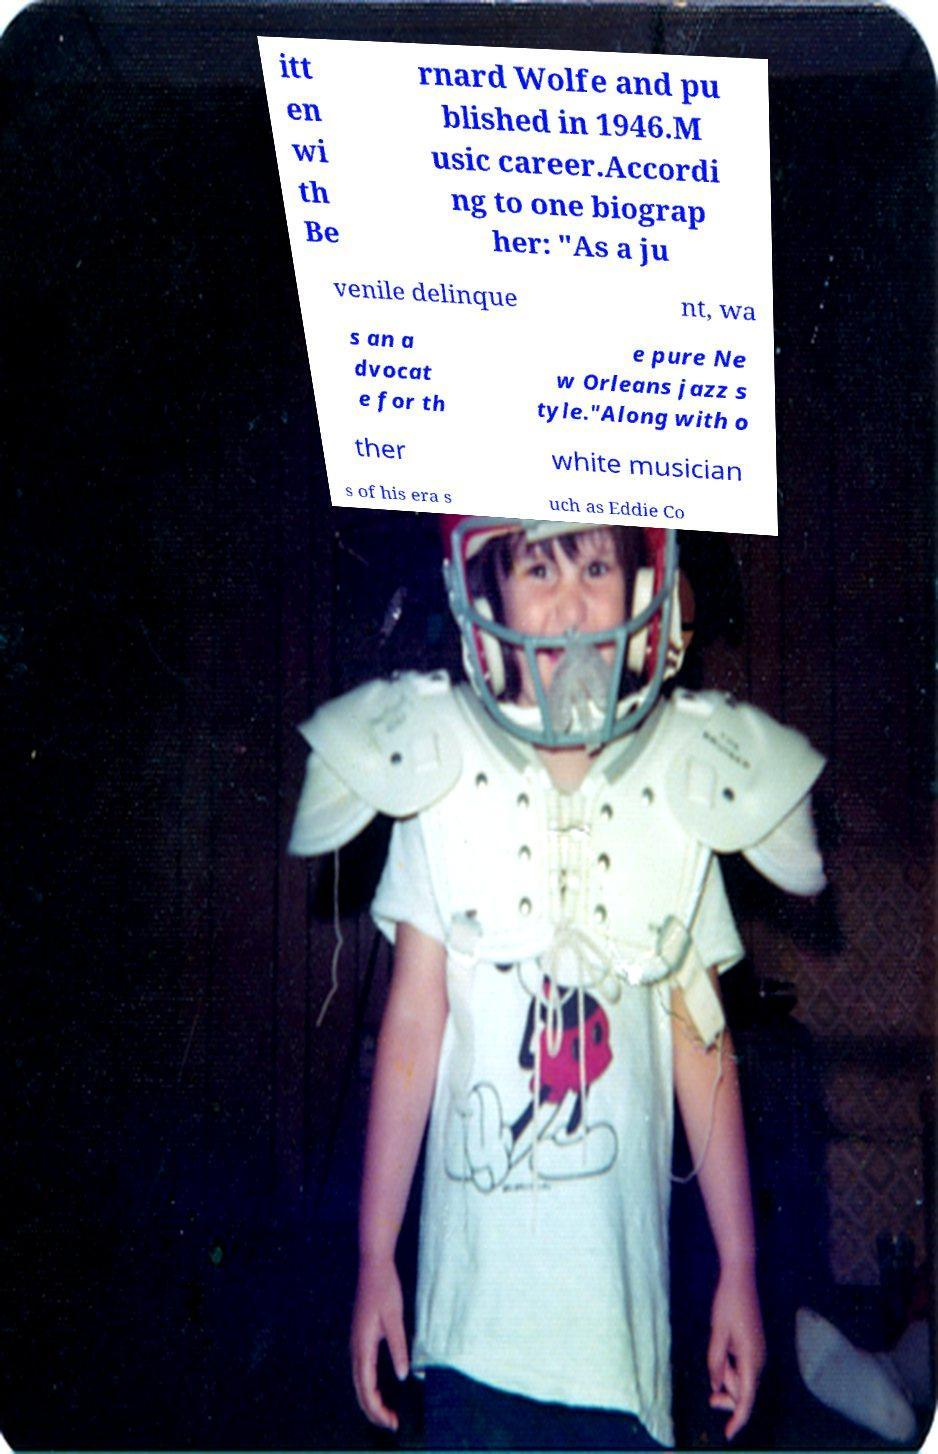I need the written content from this picture converted into text. Can you do that? itt en wi th Be rnard Wolfe and pu blished in 1946.M usic career.Accordi ng to one biograp her: "As a ju venile delinque nt, wa s an a dvocat e for th e pure Ne w Orleans jazz s tyle."Along with o ther white musician s of his era s uch as Eddie Co 